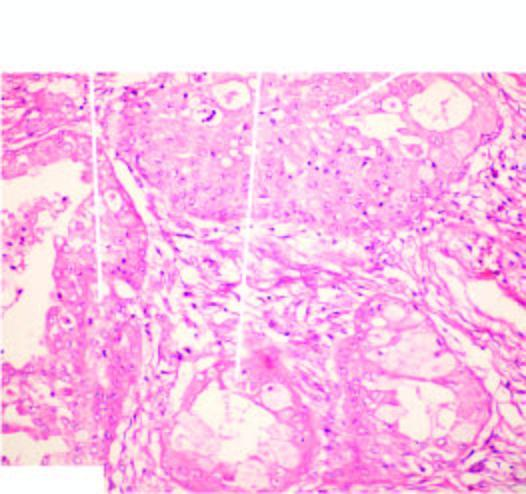does the tumour show combination of mucinous, squamous and intermediate cells?
Answer the question using a single word or phrase. Yes 